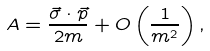Convert formula to latex. <formula><loc_0><loc_0><loc_500><loc_500>A = \frac { \vec { \sigma } \cdot \vec { p } } { 2 m } + O \left ( \frac { 1 } { m ^ { 2 } } \right ) ,</formula> 